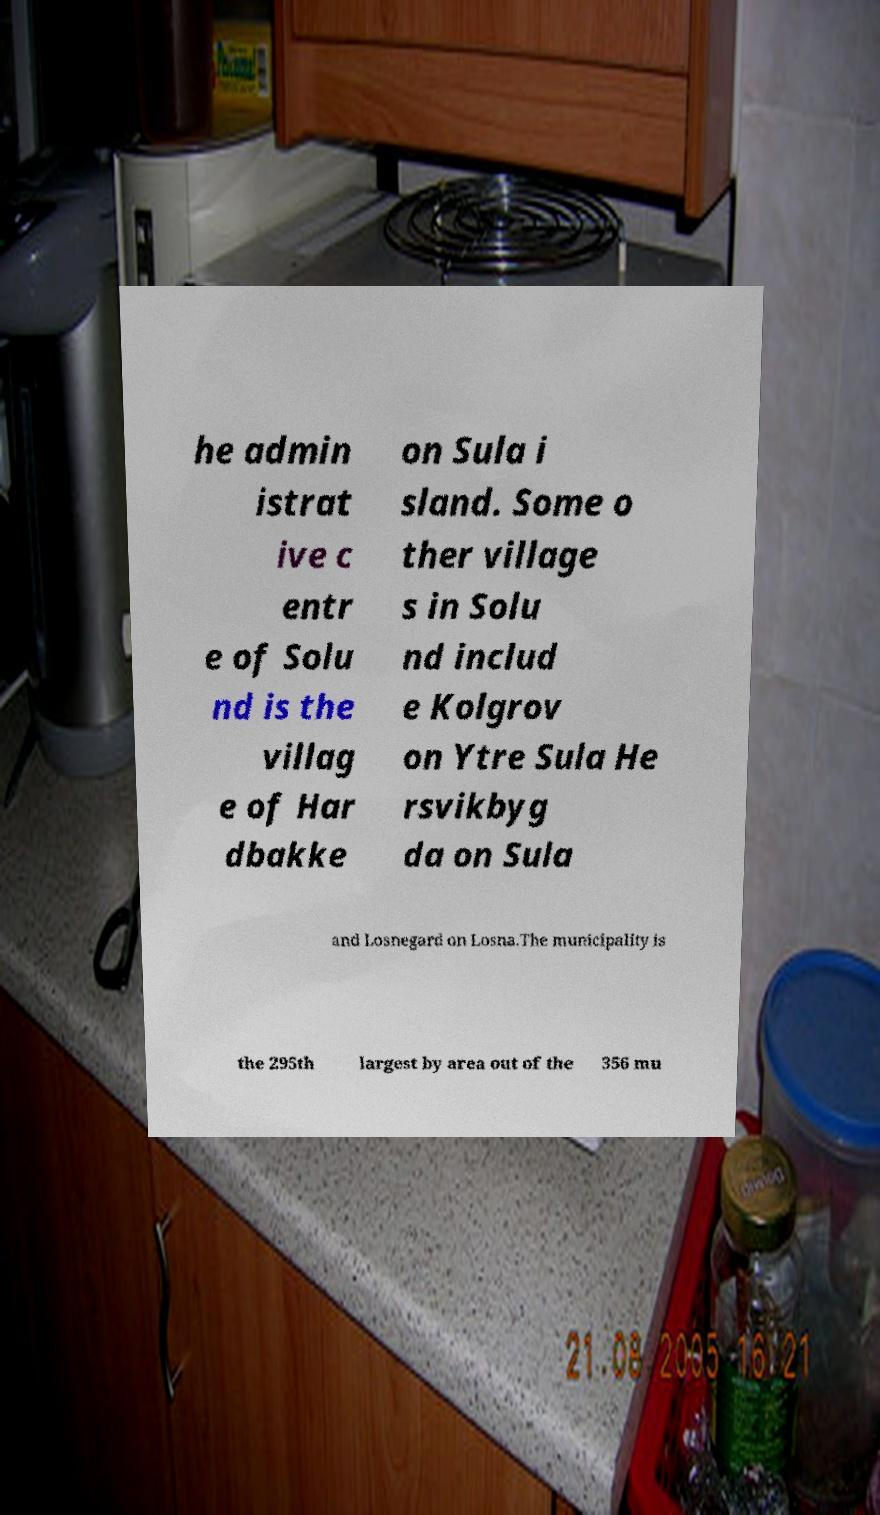Can you read and provide the text displayed in the image?This photo seems to have some interesting text. Can you extract and type it out for me? he admin istrat ive c entr e of Solu nd is the villag e of Har dbakke on Sula i sland. Some o ther village s in Solu nd includ e Kolgrov on Ytre Sula He rsvikbyg da on Sula and Losnegard on Losna.The municipality is the 295th largest by area out of the 356 mu 